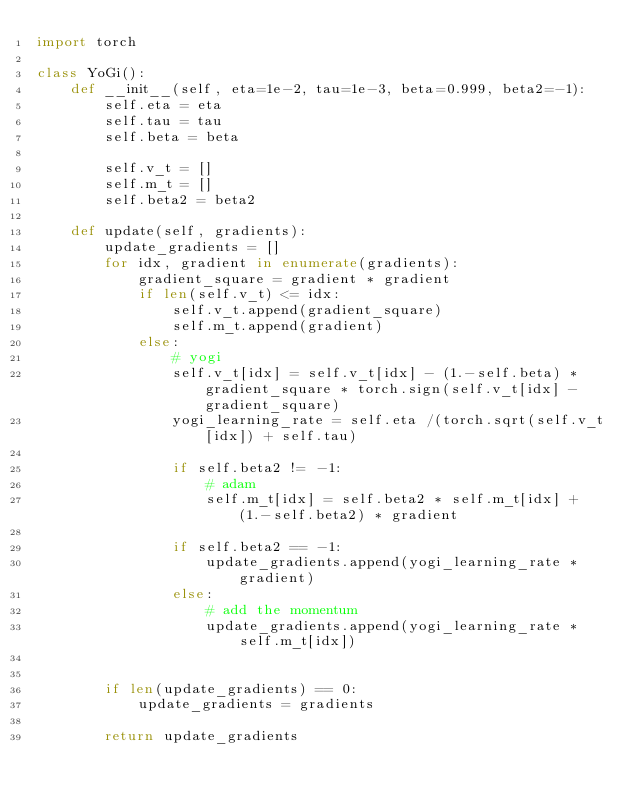Convert code to text. <code><loc_0><loc_0><loc_500><loc_500><_Python_>import torch

class YoGi():
    def __init__(self, eta=1e-2, tau=1e-3, beta=0.999, beta2=-1):
        self.eta = eta
        self.tau = tau
        self.beta = beta

        self.v_t = []
        self.m_t = []
        self.beta2 = beta2

    def update(self, gradients):
        update_gradients = []
        for idx, gradient in enumerate(gradients):
            gradient_square = gradient * gradient
            if len(self.v_t) <= idx:
                self.v_t.append(gradient_square)
                self.m_t.append(gradient)
            else:
                # yogi
                self.v_t[idx] = self.v_t[idx] - (1.-self.beta) * gradient_square * torch.sign(self.v_t[idx] - gradient_square)
                yogi_learning_rate = self.eta /(torch.sqrt(self.v_t[idx]) + self.tau)

                if self.beta2 != -1:
                    # adam
                    self.m_t[idx] = self.beta2 * self.m_t[idx] + (1.-self.beta2) * gradient

                if self.beta2 == -1:
                    update_gradients.append(yogi_learning_rate * gradient)
                else:
                    # add the momentum
                    update_gradients.append(yogi_learning_rate * self.m_t[idx])


        if len(update_gradients) == 0:
            update_gradients = gradients

        return update_gradients
</code> 